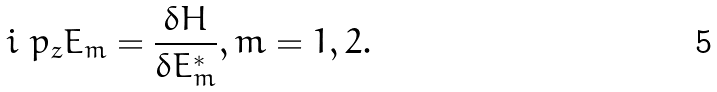Convert formula to latex. <formula><loc_0><loc_0><loc_500><loc_500>i \ p _ { z } E _ { m } = \frac { \delta H } { \delta E _ { m } ^ { * } } , m = 1 , 2 .</formula> 